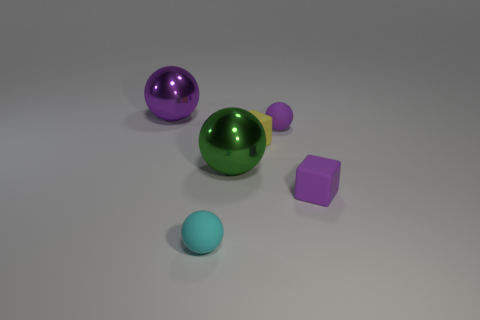There is a large shiny object that is right of the purple shiny thing behind the tiny cyan matte thing; what shape is it?
Your response must be concise. Sphere. How many tiny purple objects have the same material as the green object?
Provide a short and direct response. 0. What is the large ball in front of the purple metallic sphere made of?
Your answer should be compact. Metal. The yellow rubber object that is right of the small thing in front of the small matte block that is on the right side of the tiny purple matte ball is what shape?
Your answer should be compact. Cube. There is a small block that is right of the small yellow matte block; does it have the same color as the block that is behind the purple rubber cube?
Offer a very short reply. No. Is the number of small purple rubber balls right of the cyan rubber thing less than the number of spheres that are to the left of the tiny purple ball?
Your answer should be compact. Yes. There is another small rubber thing that is the same shape as the small yellow rubber object; what color is it?
Your response must be concise. Purple. There is a cyan matte thing; is its shape the same as the metal thing that is behind the yellow object?
Your response must be concise. Yes. How many things are either purple rubber things that are behind the tiny purple matte cube or matte cubes behind the purple matte cube?
Your answer should be very brief. 2. What is the small cyan sphere made of?
Provide a short and direct response. Rubber. 